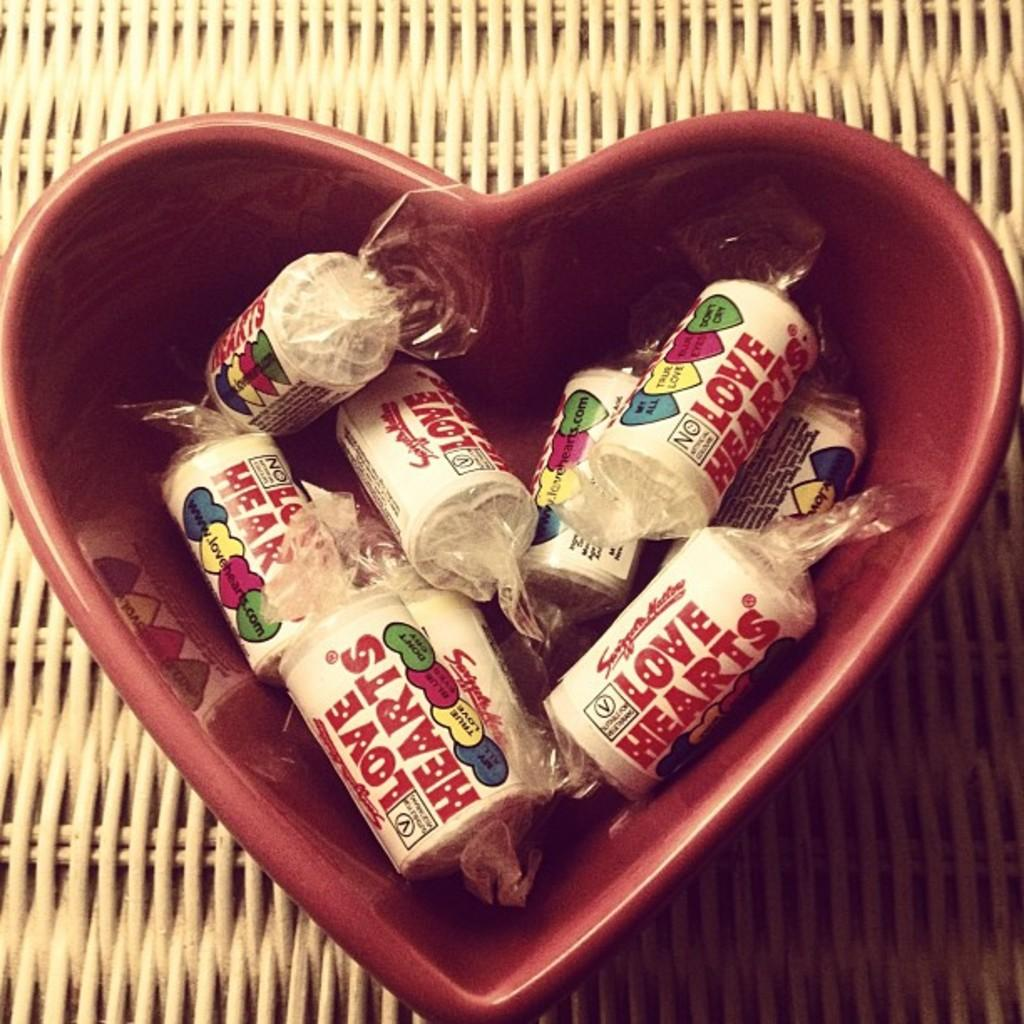What is the shape of the bowl in the image? The bowl is in a heart shape. What color is the heart-shaped bowl? The bowl is red in color. What is inside the heart-shaped bowl? The bowl contains toffees. What type of lipstick is the cook wearing in the image? There is no cook or lipstick present in the image; it features a heart-shaped bowl containing toffees. What kind of haircut does the person in the image have? There is no person present in the image; it features a heart-shaped bowl containing toffees. 